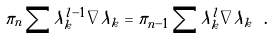Convert formula to latex. <formula><loc_0><loc_0><loc_500><loc_500>\pi _ { n } \sum \lambda _ { k } ^ { l - 1 } \nabla \lambda _ { k } = \pi _ { n - 1 } \sum \lambda _ { k } ^ { l } \nabla \lambda _ { k } \ .</formula> 